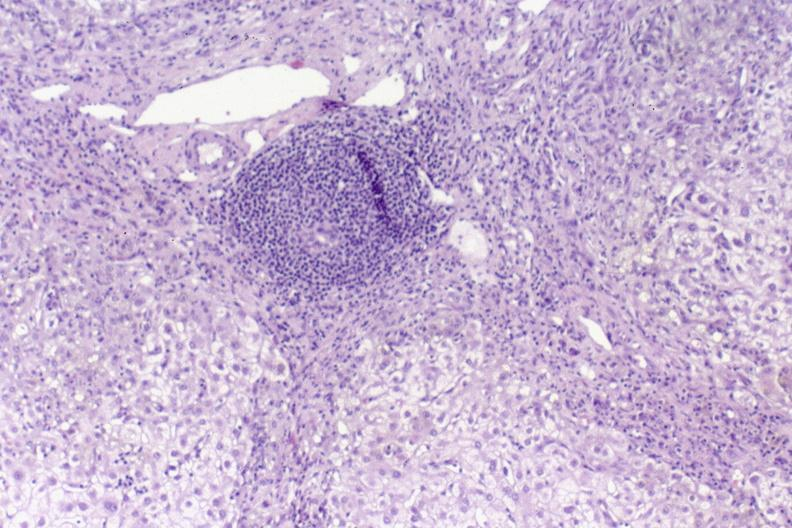s hepatobiliary present?
Answer the question using a single word or phrase. Yes 